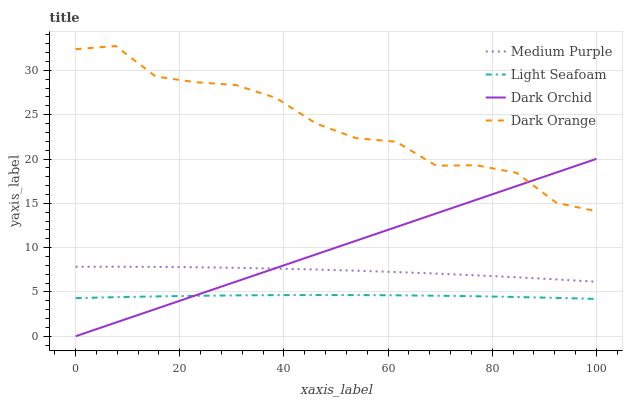Does Light Seafoam have the minimum area under the curve?
Answer yes or no. Yes. Does Dark Orange have the maximum area under the curve?
Answer yes or no. Yes. Does Dark Orange have the minimum area under the curve?
Answer yes or no. No. Does Light Seafoam have the maximum area under the curve?
Answer yes or no. No. Is Dark Orchid the smoothest?
Answer yes or no. Yes. Is Dark Orange the roughest?
Answer yes or no. Yes. Is Light Seafoam the smoothest?
Answer yes or no. No. Is Light Seafoam the roughest?
Answer yes or no. No. Does Dark Orchid have the lowest value?
Answer yes or no. Yes. Does Light Seafoam have the lowest value?
Answer yes or no. No. Does Dark Orange have the highest value?
Answer yes or no. Yes. Does Light Seafoam have the highest value?
Answer yes or no. No. Is Light Seafoam less than Medium Purple?
Answer yes or no. Yes. Is Dark Orange greater than Light Seafoam?
Answer yes or no. Yes. Does Dark Orchid intersect Light Seafoam?
Answer yes or no. Yes. Is Dark Orchid less than Light Seafoam?
Answer yes or no. No. Is Dark Orchid greater than Light Seafoam?
Answer yes or no. No. Does Light Seafoam intersect Medium Purple?
Answer yes or no. No. 